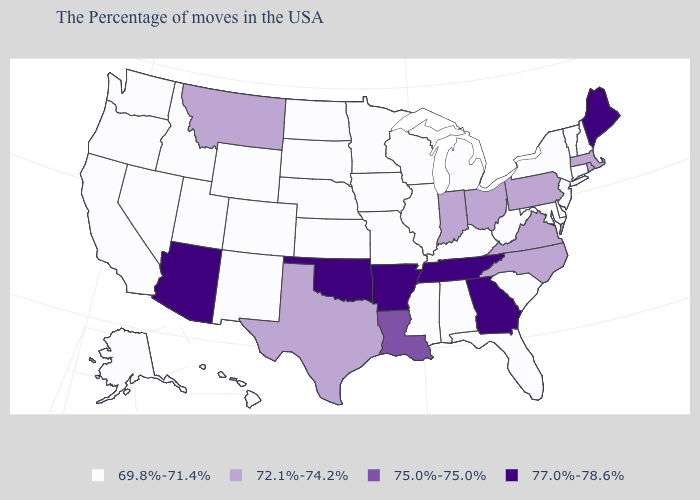What is the highest value in the USA?
Keep it brief. 77.0%-78.6%. What is the value of Tennessee?
Give a very brief answer. 77.0%-78.6%. Is the legend a continuous bar?
Keep it brief. No. Name the states that have a value in the range 77.0%-78.6%?
Answer briefly. Maine, Georgia, Tennessee, Arkansas, Oklahoma, Arizona. Name the states that have a value in the range 69.8%-71.4%?
Write a very short answer. New Hampshire, Vermont, Connecticut, New York, New Jersey, Delaware, Maryland, South Carolina, West Virginia, Florida, Michigan, Kentucky, Alabama, Wisconsin, Illinois, Mississippi, Missouri, Minnesota, Iowa, Kansas, Nebraska, South Dakota, North Dakota, Wyoming, Colorado, New Mexico, Utah, Idaho, Nevada, California, Washington, Oregon, Alaska, Hawaii. Which states have the highest value in the USA?
Answer briefly. Maine, Georgia, Tennessee, Arkansas, Oklahoma, Arizona. Does Ohio have the lowest value in the MidWest?
Give a very brief answer. No. Does New York have the highest value in the Northeast?
Short answer required. No. What is the lowest value in the MidWest?
Write a very short answer. 69.8%-71.4%. Name the states that have a value in the range 72.1%-74.2%?
Short answer required. Massachusetts, Rhode Island, Pennsylvania, Virginia, North Carolina, Ohio, Indiana, Texas, Montana. What is the highest value in states that border Idaho?
Keep it brief. 72.1%-74.2%. Among the states that border Iowa , which have the lowest value?
Answer briefly. Wisconsin, Illinois, Missouri, Minnesota, Nebraska, South Dakota. Among the states that border Kansas , does Nebraska have the lowest value?
Write a very short answer. Yes. What is the lowest value in states that border Maryland?
Write a very short answer. 69.8%-71.4%. How many symbols are there in the legend?
Concise answer only. 4. 